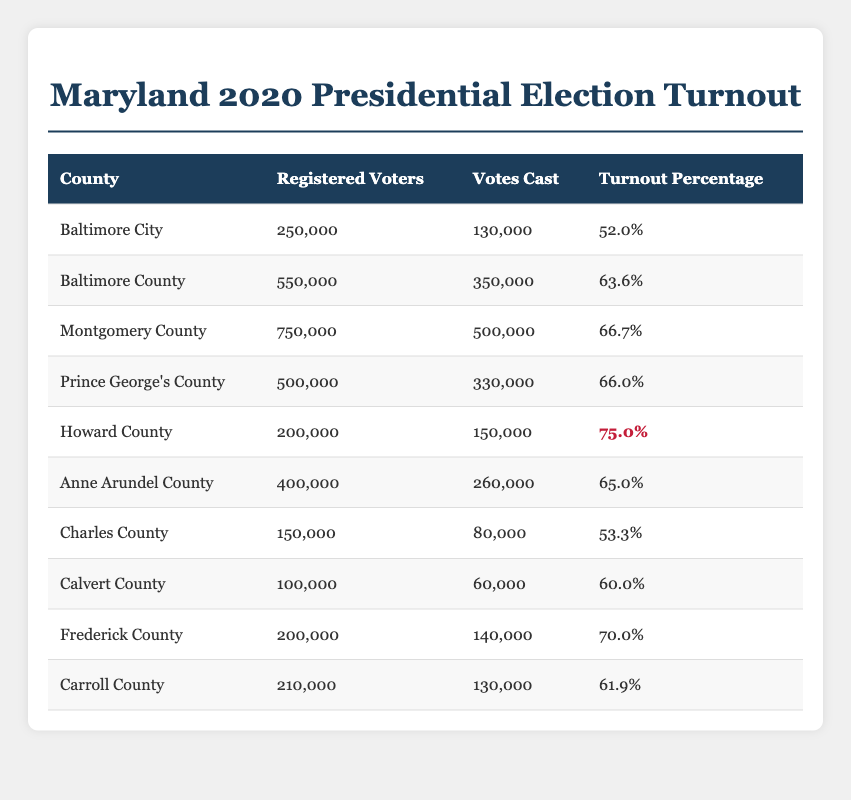What is the turnout percentage for Howard County? The table lists Howard County with a turnout percentage of 75.0%.
Answer: 75.0% Which county had the highest number of registered voters? In the table, Montgomery County shows the highest number of registered voters at 750,000.
Answer: Montgomery County How many votes were cast in Anne Arundel County? According to the table, Anne Arundel County had 260,000 votes cast.
Answer: 260,000 What is the difference in turnout percentage between Baltimore City and Montgomery County? Baltimore City has a turnout percentage of 52.0% and Montgomery County has 66.7%. The difference is 66.7% - 52.0% = 14.7%.
Answer: 14.7% What is the total number of votes cast in all counties combined? By adding the votes cast from each county: 130,000 + 350,000 + 500,000 + 330,000 + 150,000 + 260,000 + 80,000 + 60,000 + 140,000 + 130,000 = 1,680,000.
Answer: 1,680,000 Which county has a turnout percentage lower than the overall Maryland state average of 66%? The counties with lower turnout percentages than 66% are Baltimore City (52.0%), Charles County (53.3%), and Calvert County (60.0%).
Answer: Baltimore City, Charles County, Calvert County What percentage of registered voters in Baltimore County voted in the election? The table provides a turnout percentage for Baltimore County as 63.6%, indicating that this percentage of registered voters participated.
Answer: 63.6% If you combine the votes cast in Frederick County and Montgomery County, what is the total? Votes cast in Frederick County are 140,000 and in Montgomery County are 500,000. Their combined total is 140,000 + 500,000 = 640,000.
Answer: 640,000 Is the turnout percentage in Prince George's County greater than that in Charles County? The table shows Prince George's County at 66.0% and Charles County at 53.3%. Since 66.0% > 53.3%, the statement is true.
Answer: Yes What is the average turnout percentage across all counties in the table? To find the average, sum the turnout percentages: (52.0 + 63.6 + 66.7 + 66.0 + 75.0 + 65.0 + 53.3 + 60.0 + 70.0 + 61.9) / 10 = 64.5%.
Answer: 64.5% How many counties had a turnout percentage higher than 65%? The counties with turnout percentages higher than 65% are Montgomery County (66.7%), Prince George's County (66.0%), Howard County (75.0%), and Frederick County (70.0%). Thus, there are 4 counties.
Answer: 4 